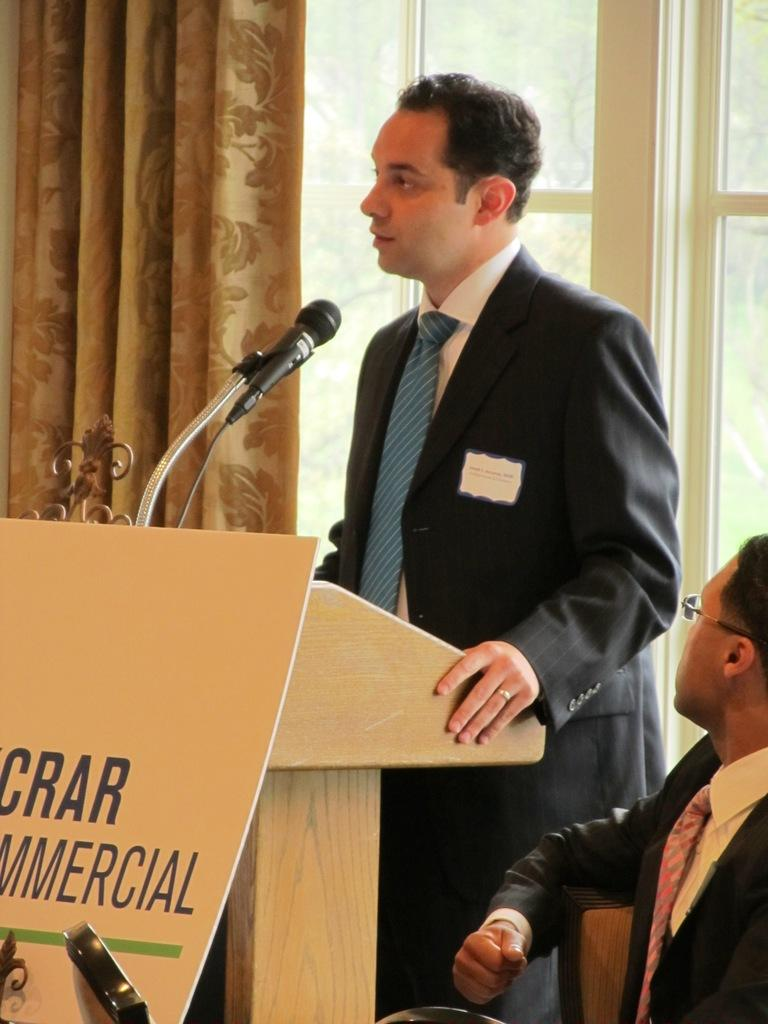How many people are present in the image? There are people in the image, but the exact number cannot be determined from the provided facts. What type of wooden object can be seen in the image? There is a wooden object in the image, but its specific form or function cannot be determined from the provided facts. What is the purpose of the curtain in the image? The purpose of the curtain in the image cannot be determined from the provided facts. What is the window in the image used for? The window in the image is used for providing a view of the outdoors, as trees are visible through it. What is the microphone in the image used for? The microphone in the image is likely used for amplifying sound or recording audio, but its specific purpose cannot be determined from the provided facts. What type of mask is being worn by the people in the image? There is no mention of masks or any facial coverings in the provided facts, so it cannot be determined if any masks are present in the image. 